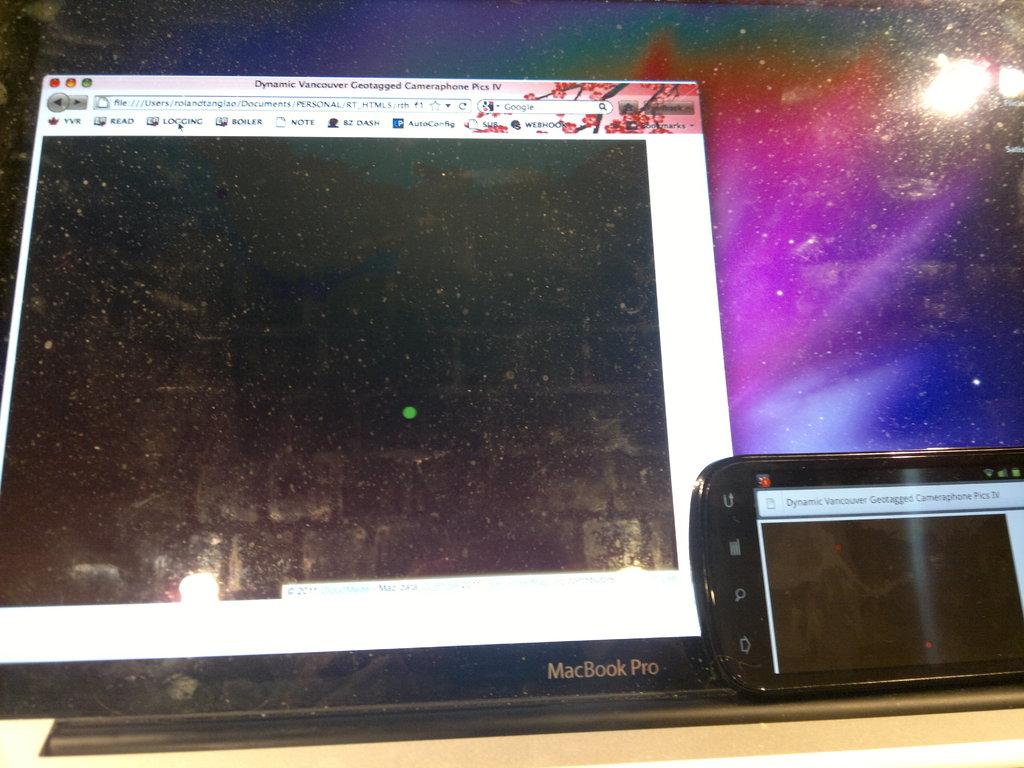What kind of computer is this?
Provide a succinct answer. Macbook pro. What is the name on the bottom of the monitor?
Provide a short and direct response. Macbook pro. 